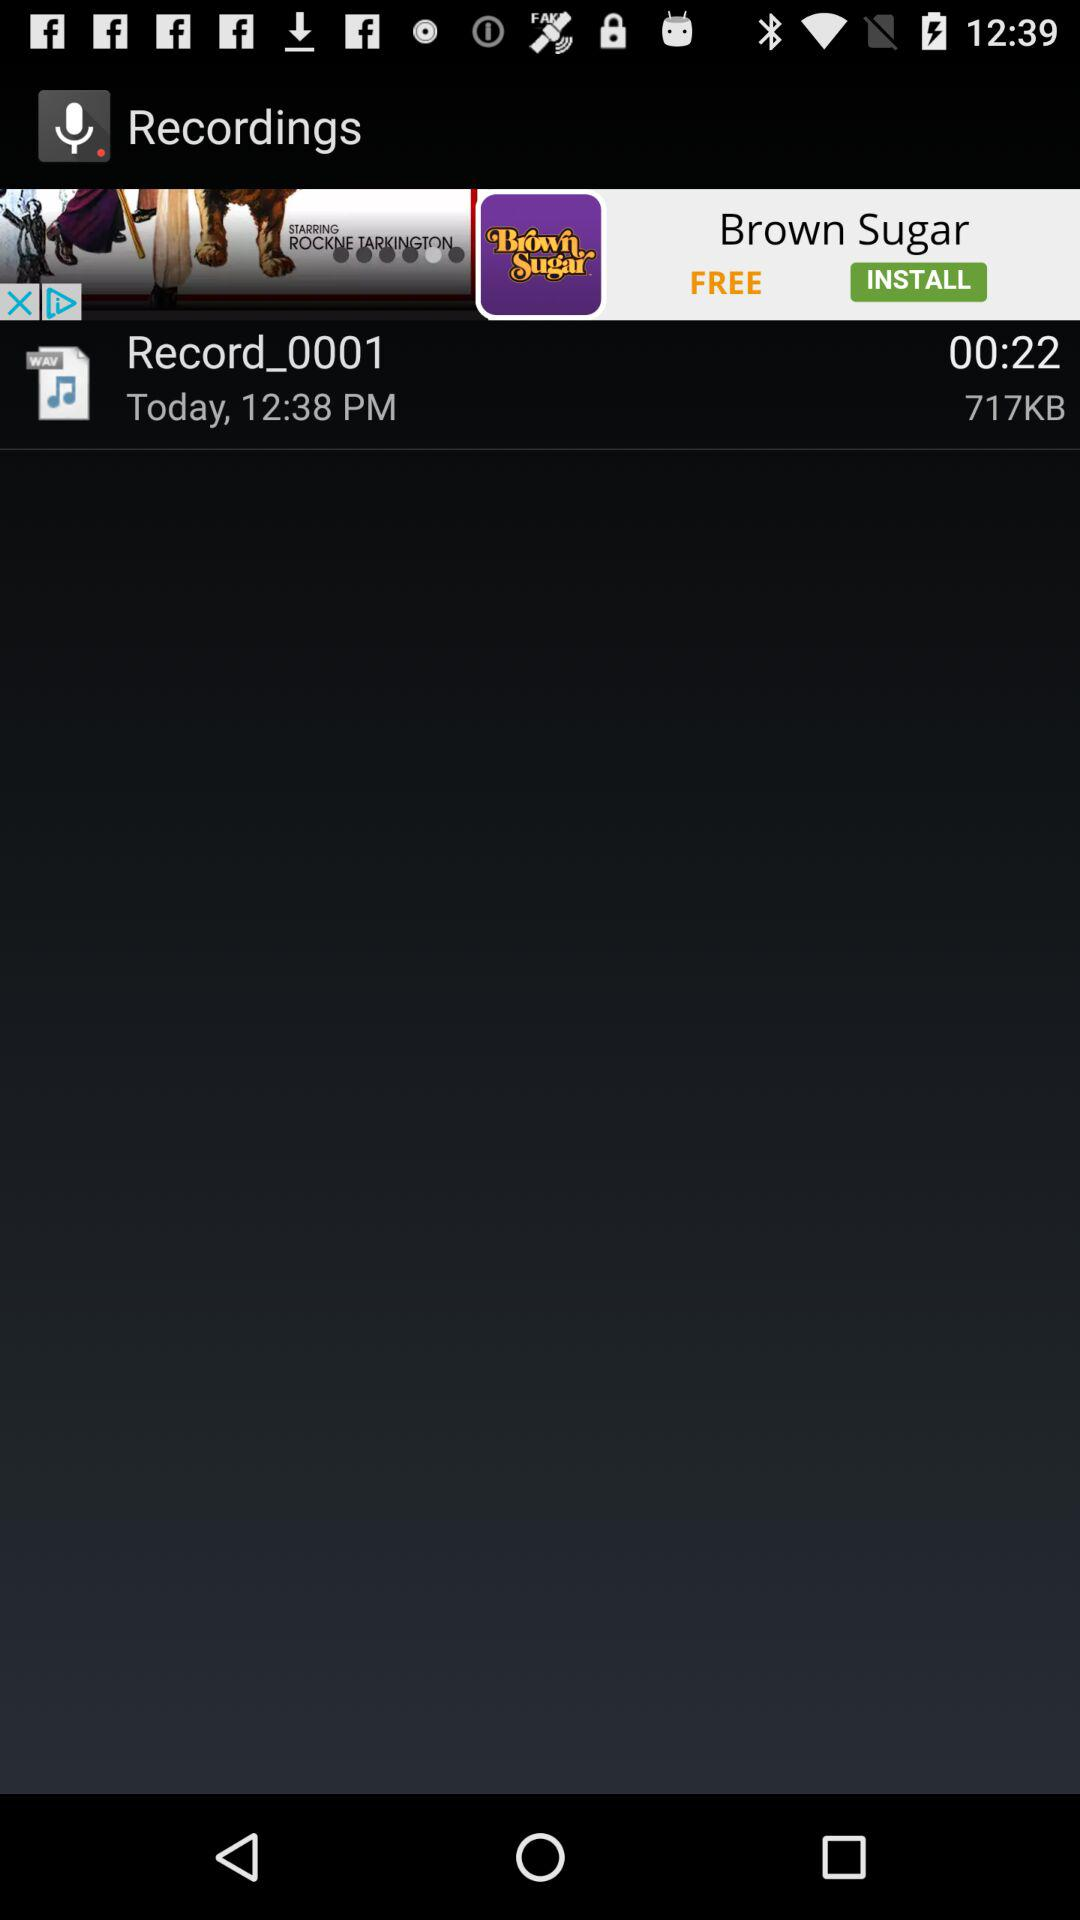What is the size of this recording? The size of the recording is 717KB. 